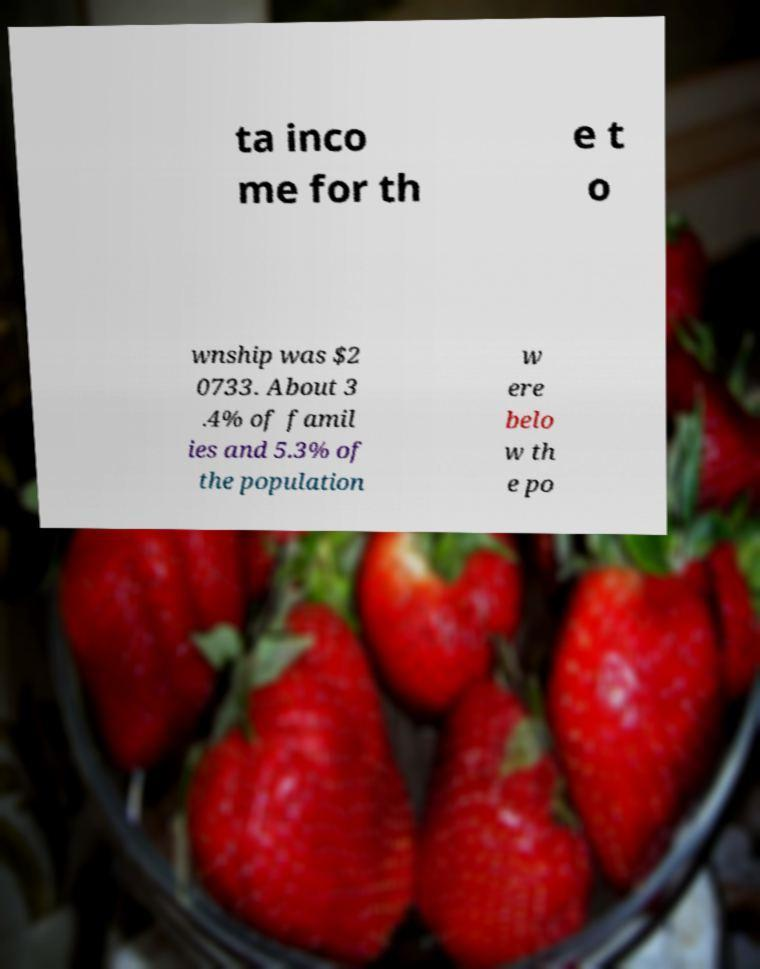I need the written content from this picture converted into text. Can you do that? ta inco me for th e t o wnship was $2 0733. About 3 .4% of famil ies and 5.3% of the population w ere belo w th e po 